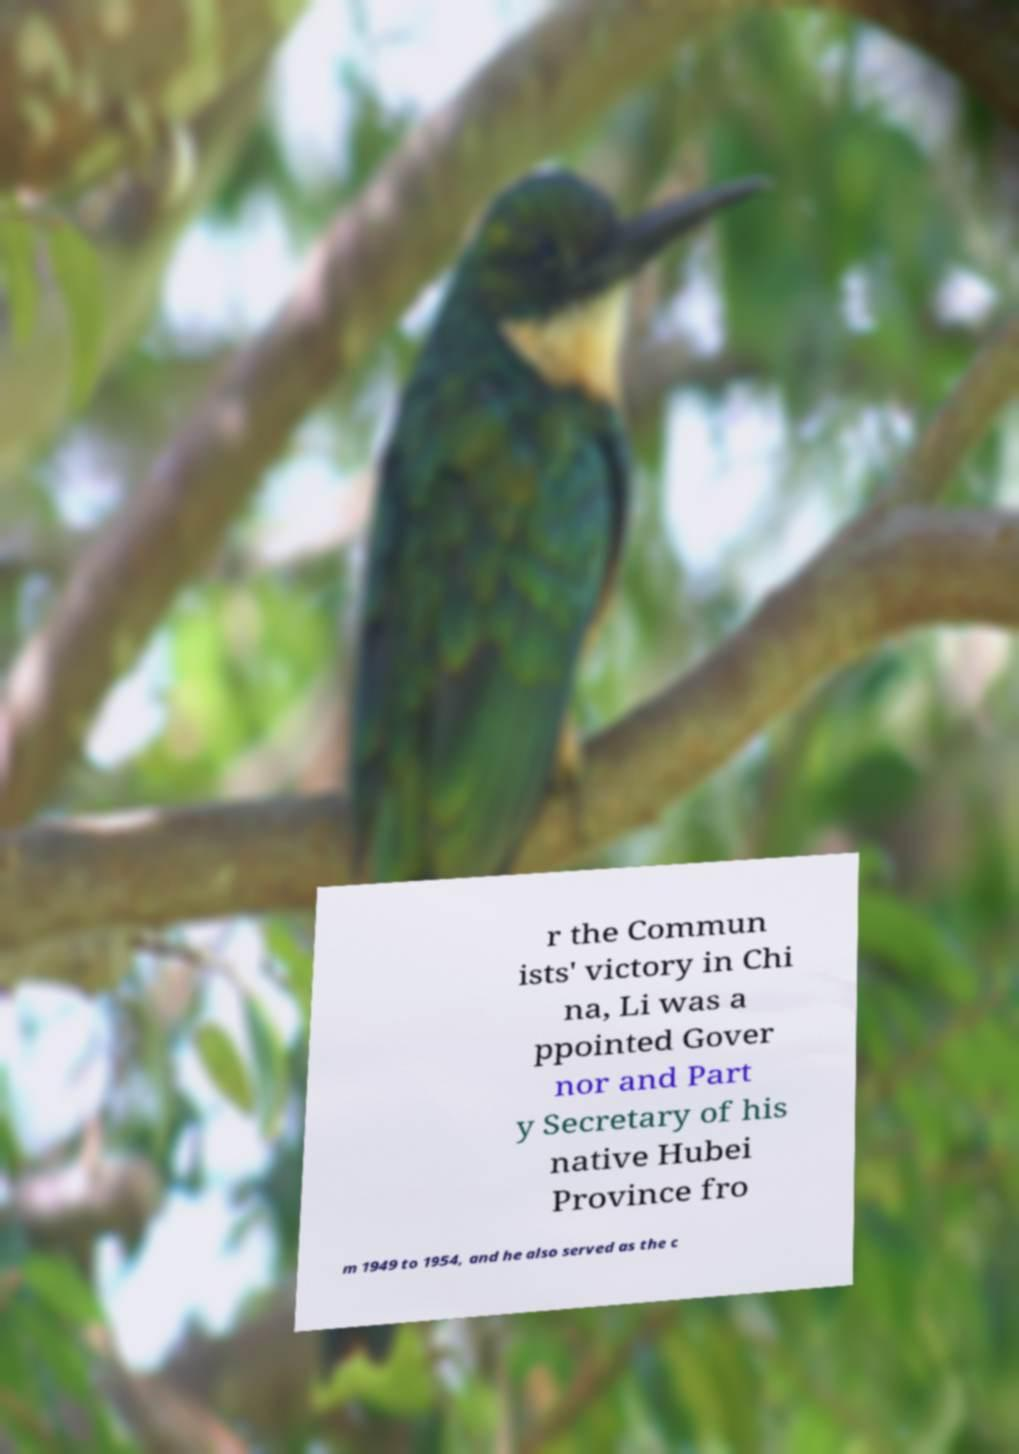For documentation purposes, I need the text within this image transcribed. Could you provide that? r the Commun ists' victory in Chi na, Li was a ppointed Gover nor and Part y Secretary of his native Hubei Province fro m 1949 to 1954, and he also served as the c 